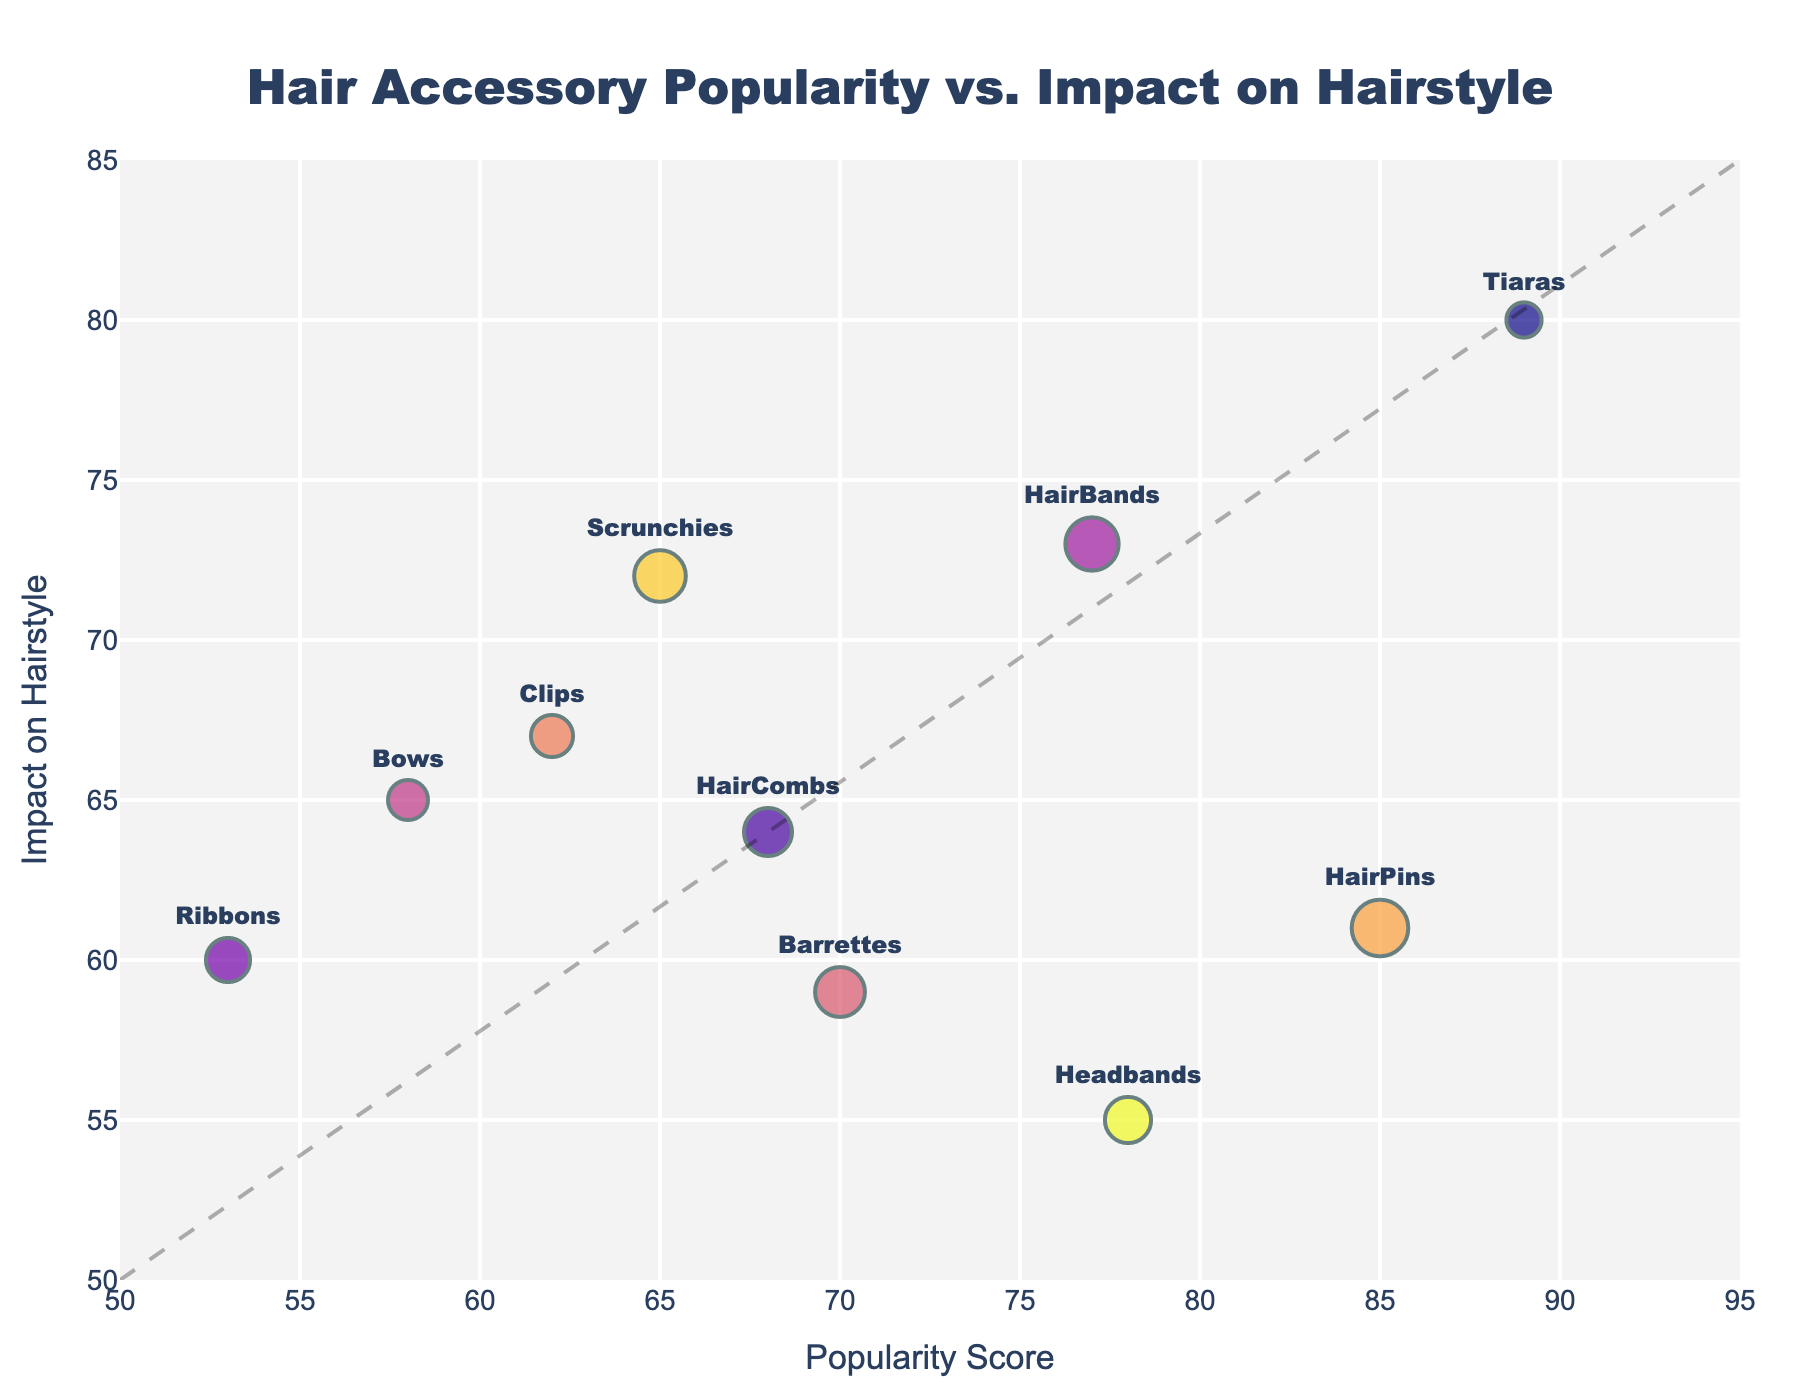How many types of hair accessories are displayed in the plot? Count the number of distinct accessory types listed in the legend or available in the plot's hover information.
Answer: 10 Which hair accessory has the highest Popularity Score? Check which data point is the furthest to the right on the x-axis, and identify its accessory type using the hover information or labels.
Answer: Tiaras What is the Trend Duration (in months) for HairBands? Find the data point for HairBands and look at the bubble size which corresponds to the Trend Duration in months, or hover over the data point to see the value.
Answer: 16 Compare the Trend Duration for Scrunchies and Bows. Which one lasts longer? Identify the data points for Scrunchies and Bows, then compare their bubble sizes or hover over them to see the exact Trend Duration values.
Answer: Scrunchies What's the relationship between Popularity Score and Impact on Hairstyle for most accessories? Observe if there's a general trend or pattern among the positions of the data points on the scatter plot.
Answer: Positive correlation Which accessory has the largest impact on hairstyle but relatively short trend duration? Look for the data point with a high y-value (Impact on Hairstyle) and a small bubble size (short Trend Duration), then identify its accessory type.
Answer: Tiaras Between Headbands and Clips, which has a higher Impact on Hairstyle? Identify the y-values (Impact on Hairstyle) for both Headbands and Clips, and compare them to determine which one is higher.
Answer: Clips What is the average Popularity Score of Accessories with more than 60 Impact on Hairstyle? Identify the data points with an Impact on Hairstyle greater than 60, sum their Popularity Scores, and divide by the number of such points: (85 + 62 + 65 + 77 + 68 + 89) / 6 = 74.333.
Answer: 74.333 Is there any accessory with a higher Popularity Score than HairPins but lower Impact on Hairstyle? Compare HairPins' values (Popularity Score of 85 and Impact on Hairstyle of 61) with other data points to find an accessory with a higher Popularity Score and lower Impact on Hairstyle.
Answer: No 